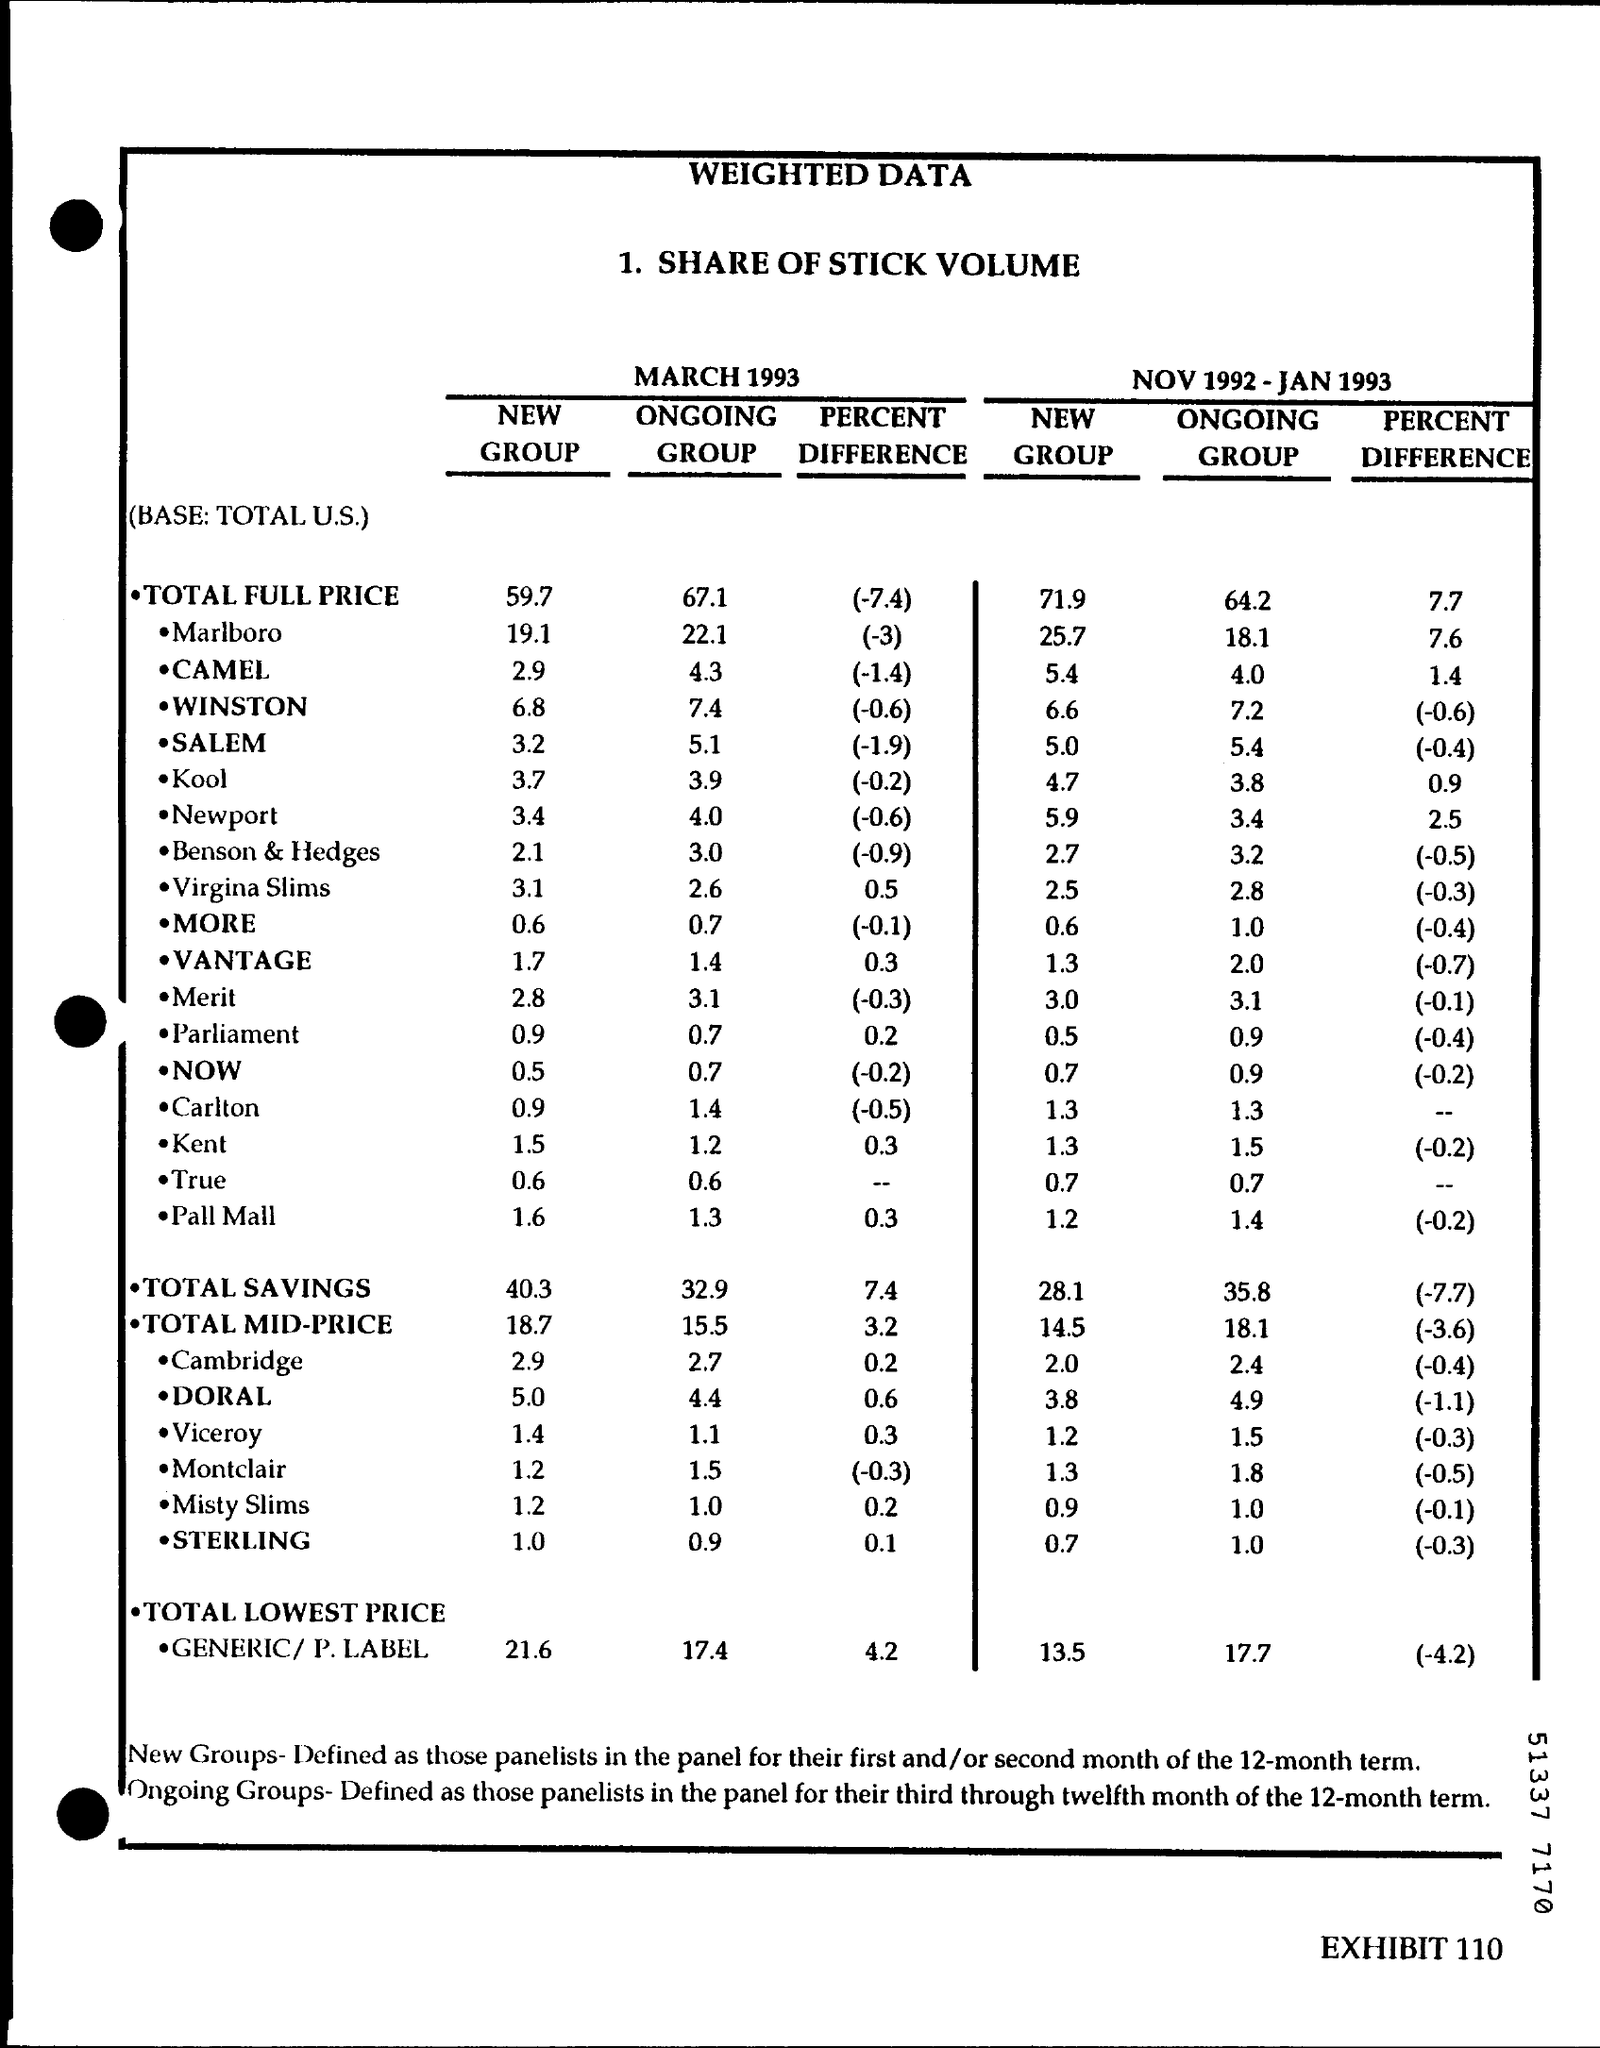What is the Title of the document?
Make the answer very short. Weighted Data. What is the Total Full Price for New Group for March 1993?
Make the answer very short. 59.7. What is the Total Full Price for New Group for NOV 1992 - JAN 1993?
Offer a terse response. 71.9. What is the Total Full Price for Ongoing Group for March 1993?
Your answer should be very brief. 67.1. What is the Total Full Price Percent Difference for March 1993?
Provide a succinct answer. (-7.4). What is the Total Full Price for Ongoing Group for NOV 1992 - JAN 1993?
Give a very brief answer. 64.2. What is the Total Full Price Percent Difference for NOV 1992 - JAN 1993?
Keep it short and to the point. 7.7. What is the Total Savings  for New Group for NOV 1992 - JAN 1993?
Provide a succinct answer. 28.1. What is the Total Savings for New Group for March 1993?
Give a very brief answer. 40.3. What is the Total Savings for Ongoing Group for March 1993?
Offer a terse response. 32.9. 